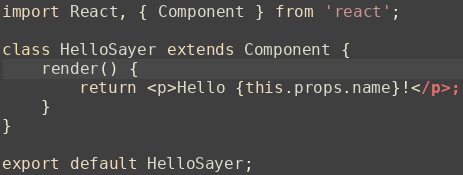Convert code to text. <code><loc_0><loc_0><loc_500><loc_500><_JavaScript_>import React, { Component } from 'react';

class HelloSayer extends Component {
	render() {
		return <p>Hello {this.props.name}!</p>;
	}
}

export default HelloSayer;
</code> 